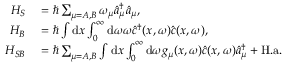Convert formula to latex. <formula><loc_0><loc_0><loc_500><loc_500>\begin{array} { r l } { H _ { S } } & = \hbar { \sum } _ { \mu = A , B } \omega _ { \mu } \hat { a } _ { \mu } ^ { \dagger } \hat { a } _ { \mu } , } \\ { H _ { B } } & = \hbar { \int } d x \int _ { 0 } ^ { \infty } d \omega \omega \hat { c } ^ { \dagger } ( x , \omega ) \hat { c } ( x , \omega ) , } \\ { H _ { S B } } & = \hbar { \sum } _ { \mu = A , B } \int d x \int _ { 0 } ^ { \infty } d \omega g _ { \mu } ( x , \omega ) \hat { c } ( x , \omega ) \hat { a } _ { \mu } ^ { \dagger } + H . a . } \end{array}</formula> 